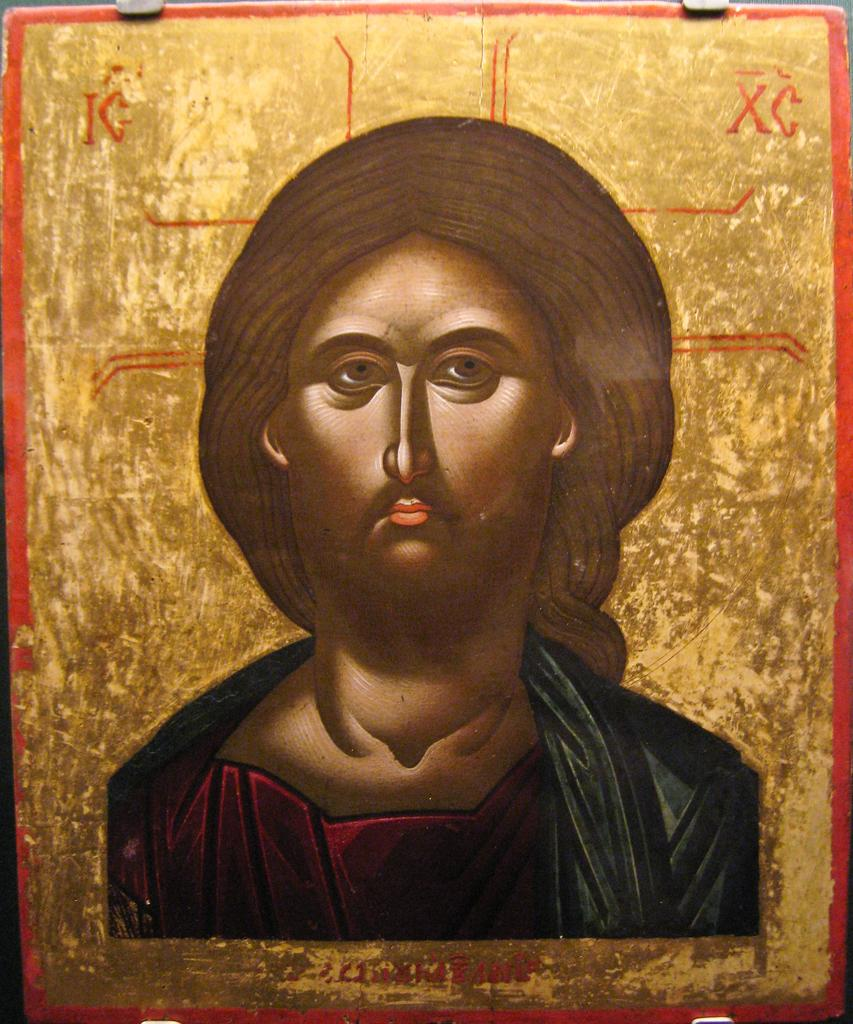What is the main subject of the image? There is a painting in the image. What does the painting depict? The painting depicts a person. What type of watch is the person wearing in the painting? There is no watch visible in the painting; it only depicts a person. What emotion is the person displaying in the painting? The painting does not convey any specific emotion, such as anger, as it only depicts a person. 